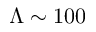<formula> <loc_0><loc_0><loc_500><loc_500>\Lambda \sim 1 0 0</formula> 